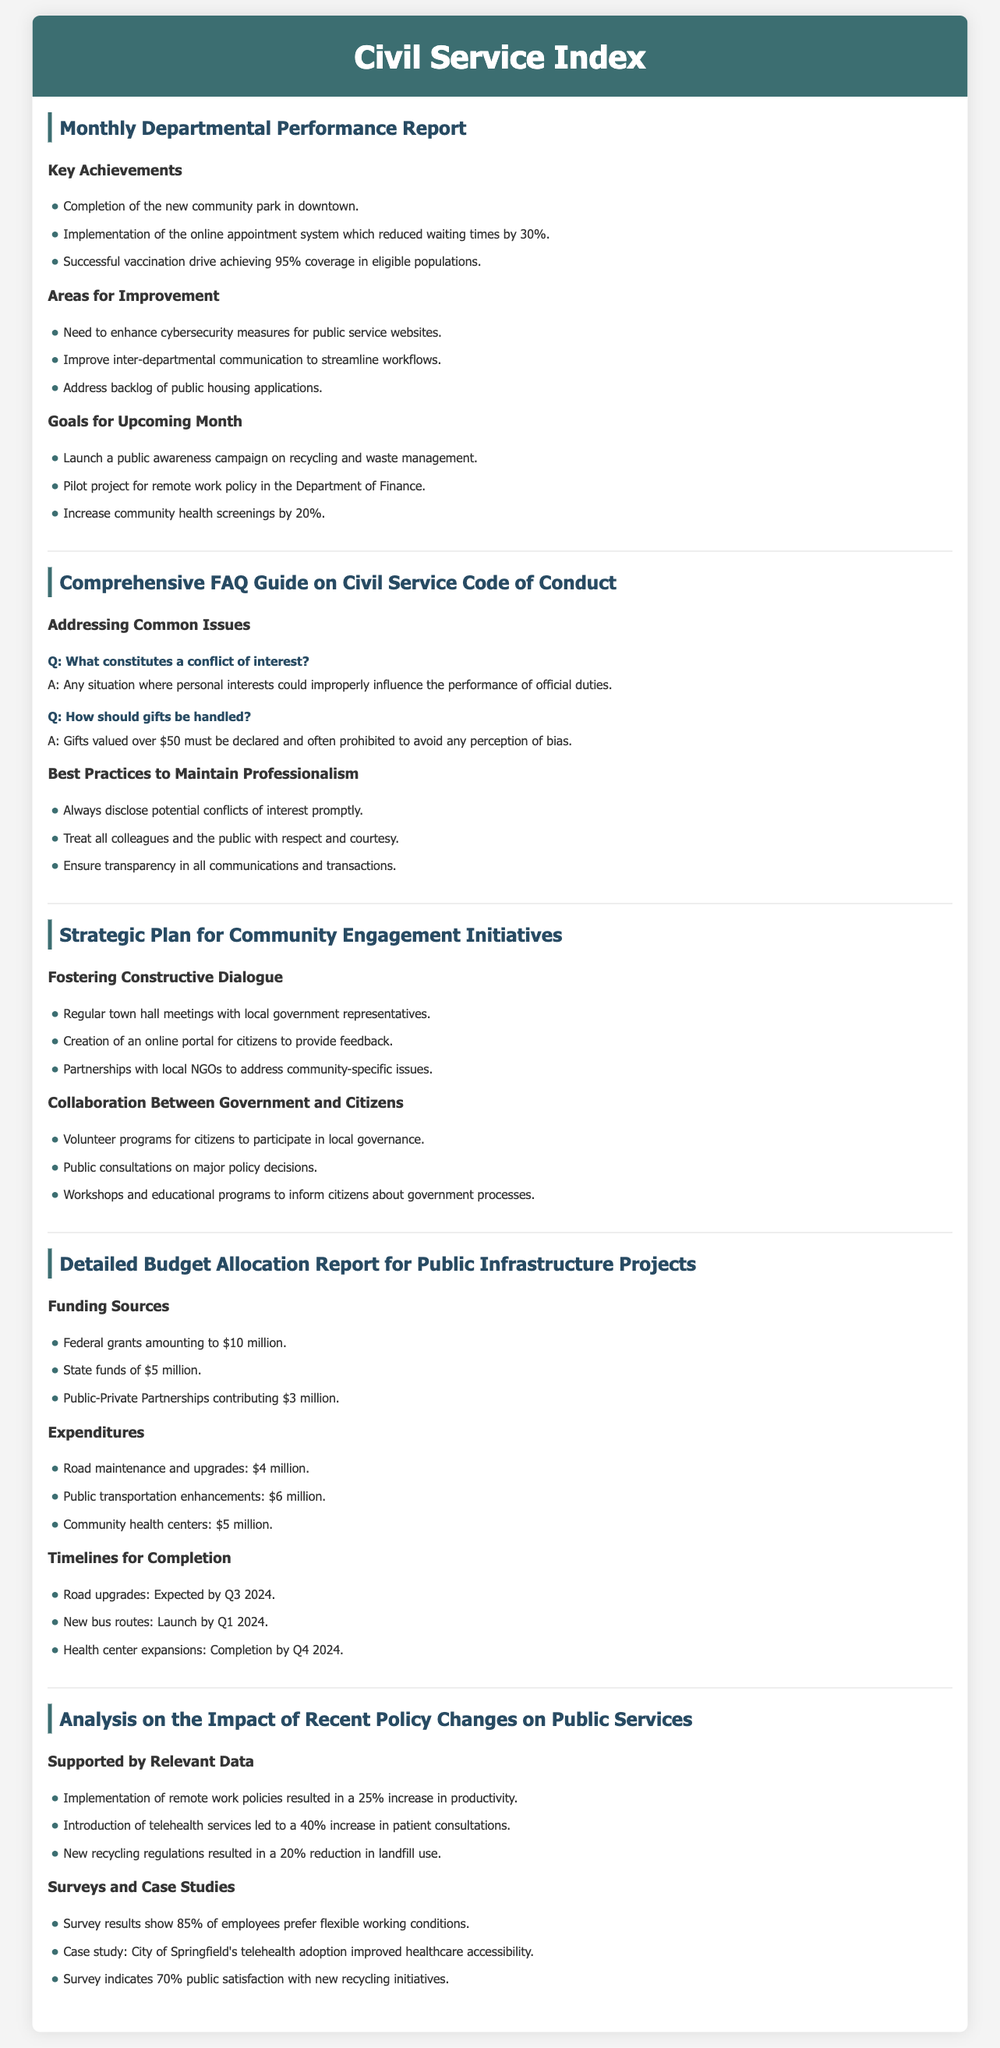What is the achievement related to the community park? The achievement pertains to the completion of the new community park in downtown, as noted in the report.
Answer: completion of the new community park in downtown What is the percentage reduction in waiting times due to the new online appointment system? According to the document, the online appointment system helped reduce waiting times by 30%.
Answer: 30% What is one area identified for improvement regarding public service websites? The report mentions the need to enhance cybersecurity measures for public service websites as an area for improvement.
Answer: enhance cybersecurity measures What is the total amount of federal grants for public infrastructure projects? The document states that federal grants amount to $10 million for public infrastructure projects.
Answer: $10 million When is the expected completion date for road upgrades? The timeline noted in the report indicates that road upgrades are expected by Q3 2024.
Answer: Q3 2024 What is the overarching goal for the upcoming month regarding health screenings? The report outlines that the goal for the upcoming month is to increase community health screenings by 20%.
Answer: increase community health screenings by 20% How many town hall meetings are planned as part of the community engagement initiatives? The document states that regular town hall meetings with local government representatives are part of fostering constructive dialogue, without specifying the number.
Answer: regular town hall meetings What is one key change that resulted from the implementation of remote work policies? The document highlights that the implementation of remote work policies led to a 25% increase in productivity.
Answer: 25% increase in productivity Which service experienced a 40% increase in consultations due to telehealth services? The document references patient consultations as having increased by 40% due to the introduction of telehealth services.
Answer: patient consultations 